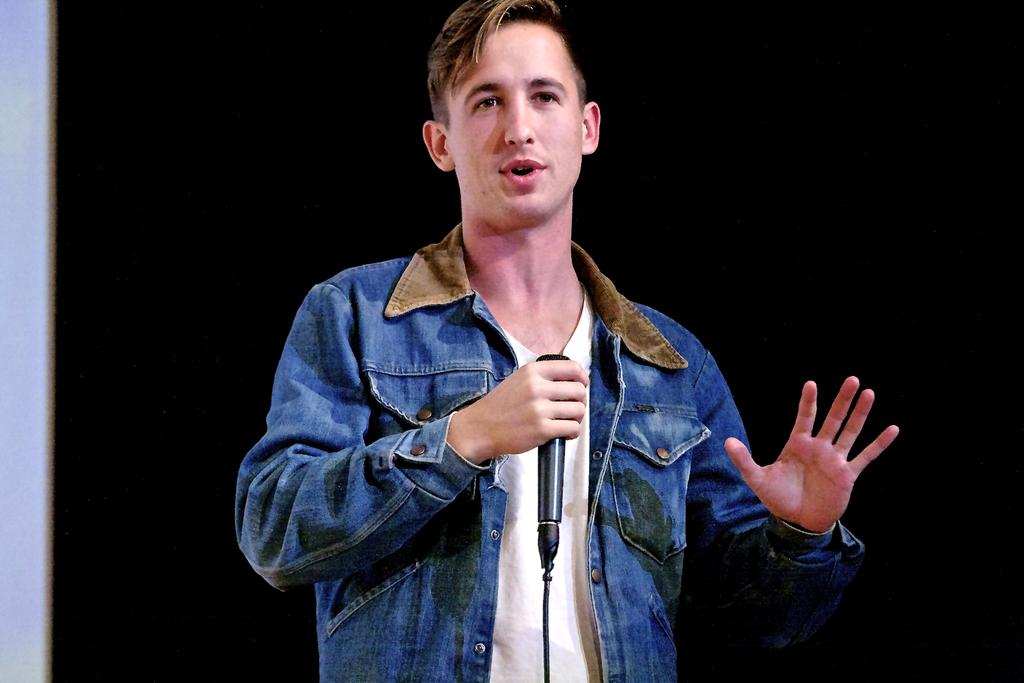What is the main subject of the image? The main subject of the image is a boy. What is the boy holding in his hand? The boy is holding a mic in his hand. What type of force is being applied to the shirt in the image? There is no shirt present in the image, and therefore no force can be applied to it. 